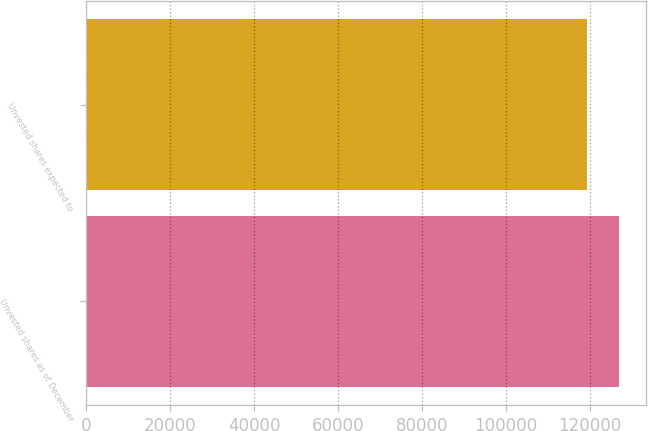Convert chart. <chart><loc_0><loc_0><loc_500><loc_500><bar_chart><fcel>Unvested shares as of December<fcel>Unvested shares expected to<nl><fcel>126928<fcel>119206<nl></chart> 